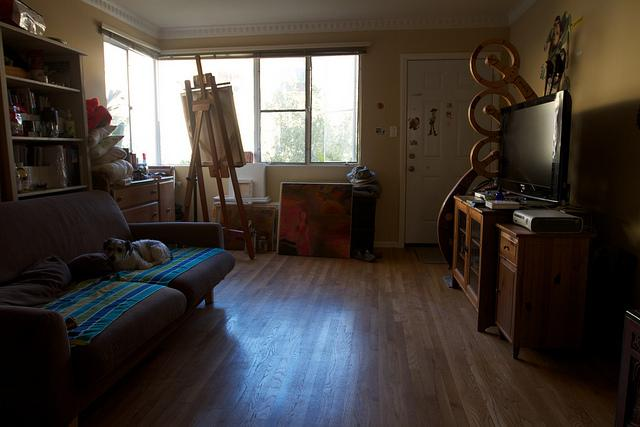What is likely on the item by the window?

Choices:
A) clothes
B) television
C) food
D) painting painting 